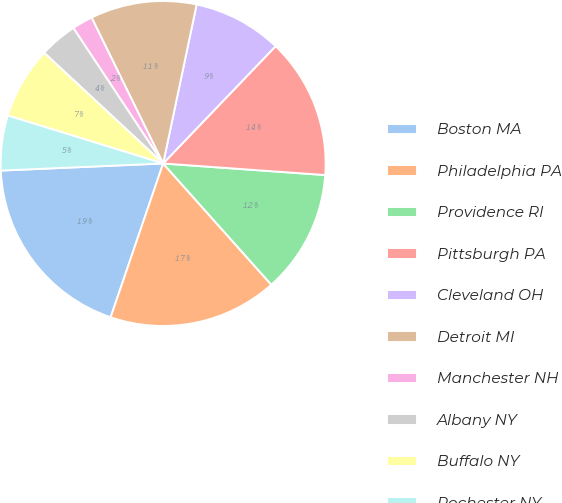Convert chart. <chart><loc_0><loc_0><loc_500><loc_500><pie_chart><fcel>Boston MA<fcel>Philadelphia PA<fcel>Providence RI<fcel>Pittsburgh PA<fcel>Cleveland OH<fcel>Detroit MI<fcel>Manchester NH<fcel>Albany NY<fcel>Buffalo NY<fcel>Rochester NY<nl><fcel>19.07%<fcel>16.83%<fcel>12.27%<fcel>13.97%<fcel>8.86%<fcel>10.56%<fcel>2.06%<fcel>3.76%<fcel>7.16%<fcel>5.46%<nl></chart> 